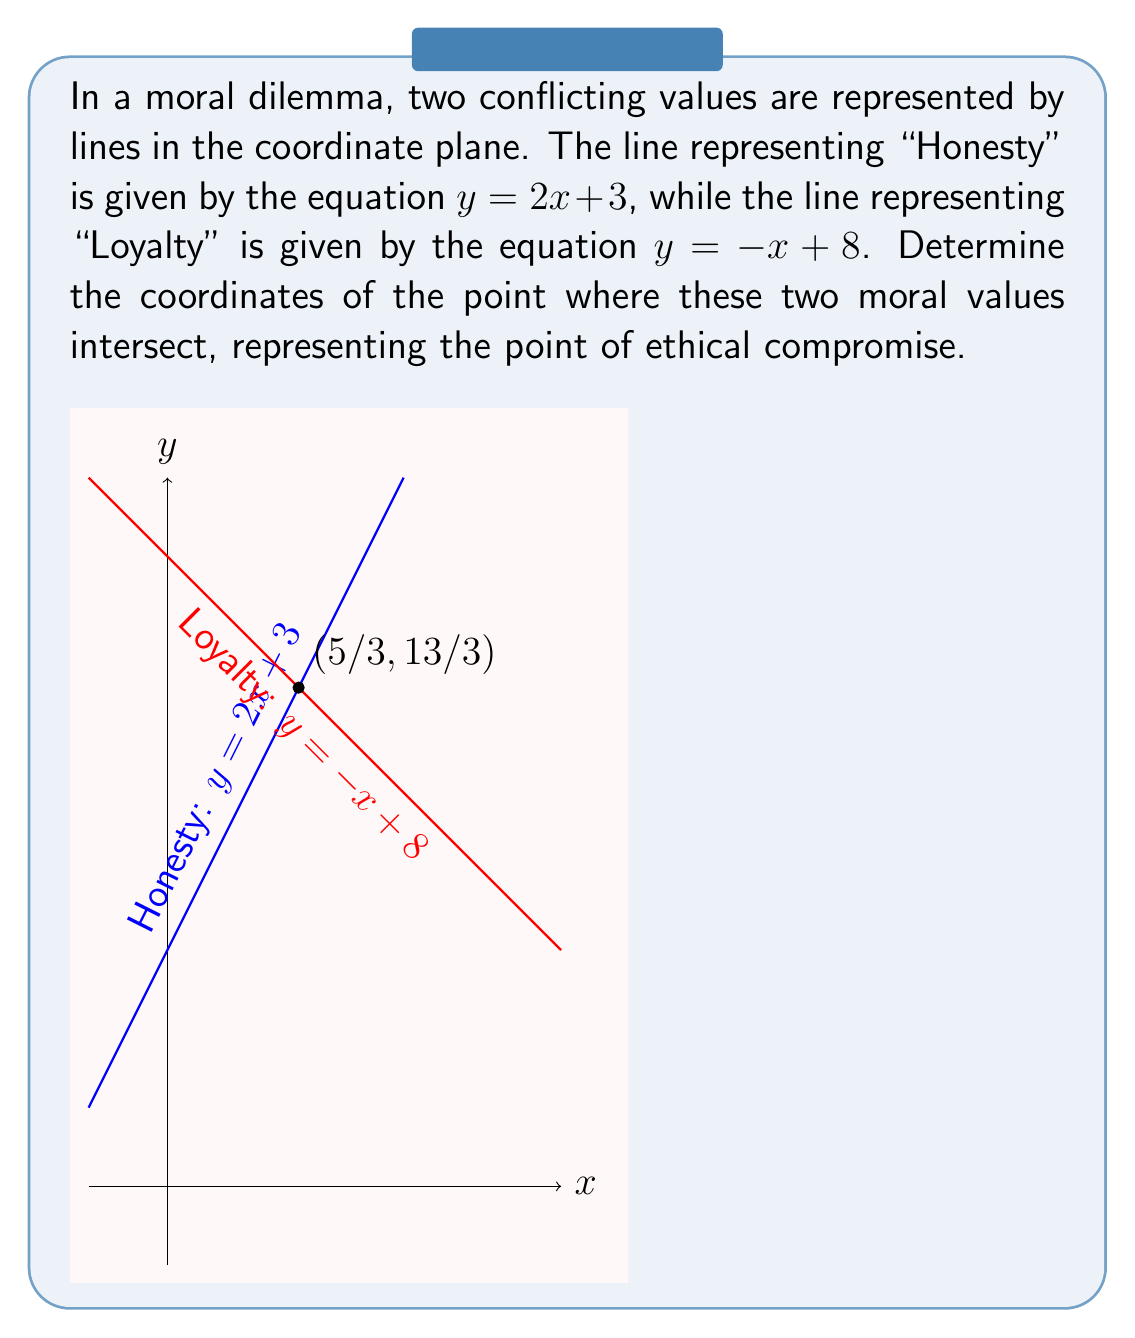Can you answer this question? To find the point of intersection between the two lines, we need to solve the system of equations:

$$\begin{cases}
y = 2x + 3 \quad \text{(Honesty)} \\
y = -x + 8 \quad \text{(Loyalty)}
\end{cases}$$

Since both equations are equal to $y$, we can set them equal to each other:

$$2x + 3 = -x + 8$$

Now, let's solve for $x$:

$$\begin{align}
2x + 3 &= -x + 8 \\
3x + 3 &= 8 \\
3x &= 5 \\
x &= \frac{5}{3}
\end{align}$$

To find the $y$-coordinate, we can substitute $x = \frac{5}{3}$ into either of the original equations. Let's use the "Honesty" equation:

$$\begin{align}
y &= 2(\frac{5}{3}) + 3 \\
&= \frac{10}{3} + 3 \\
&= \frac{10}{3} + \frac{9}{3} \\
&= \frac{19}{3}
\end{align}$$

Therefore, the point of intersection is $(\frac{5}{3}, \frac{19}{3})$.
Answer: The point of intersection between the two moral values is $(\frac{5}{3}, \frac{19}{3})$. 